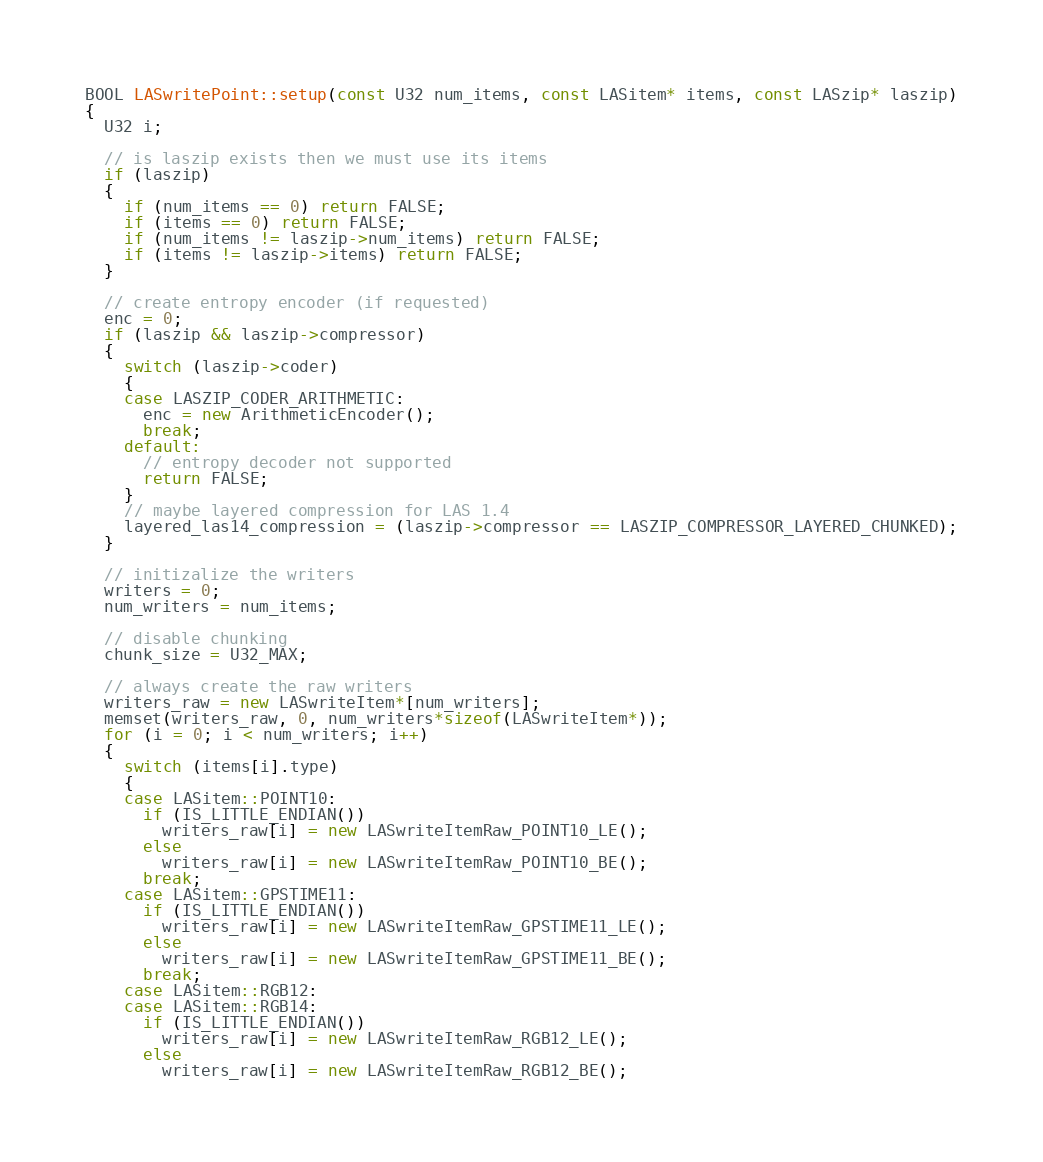Convert code to text. <code><loc_0><loc_0><loc_500><loc_500><_C++_>BOOL LASwritePoint::setup(const U32 num_items, const LASitem* items, const LASzip* laszip)
{
  U32 i;

  // is laszip exists then we must use its items
  if (laszip)
  {
    if (num_items == 0) return FALSE;
    if (items == 0) return FALSE;
    if (num_items != laszip->num_items) return FALSE;
    if (items != laszip->items) return FALSE;
  }

  // create entropy encoder (if requested)
  enc = 0;
  if (laszip && laszip->compressor)
  {
    switch (laszip->coder)
    {
    case LASZIP_CODER_ARITHMETIC:
      enc = new ArithmeticEncoder();
      break;
    default:
      // entropy decoder not supported
      return FALSE;
    }
    // maybe layered compression for LAS 1.4 
    layered_las14_compression = (laszip->compressor == LASZIP_COMPRESSOR_LAYERED_CHUNKED);
  }

  // initizalize the writers
  writers = 0;
  num_writers = num_items;

  // disable chunking
  chunk_size = U32_MAX;

  // always create the raw writers
  writers_raw = new LASwriteItem*[num_writers];
  memset(writers_raw, 0, num_writers*sizeof(LASwriteItem*));
  for (i = 0; i < num_writers; i++)
  {
    switch (items[i].type)
    {
    case LASitem::POINT10:
      if (IS_LITTLE_ENDIAN())
        writers_raw[i] = new LASwriteItemRaw_POINT10_LE();
      else
        writers_raw[i] = new LASwriteItemRaw_POINT10_BE();
      break;
    case LASitem::GPSTIME11:
      if (IS_LITTLE_ENDIAN())
        writers_raw[i] = new LASwriteItemRaw_GPSTIME11_LE();
      else
        writers_raw[i] = new LASwriteItemRaw_GPSTIME11_BE();
      break;
    case LASitem::RGB12:
    case LASitem::RGB14:
      if (IS_LITTLE_ENDIAN())
        writers_raw[i] = new LASwriteItemRaw_RGB12_LE();
      else
        writers_raw[i] = new LASwriteItemRaw_RGB12_BE();</code> 